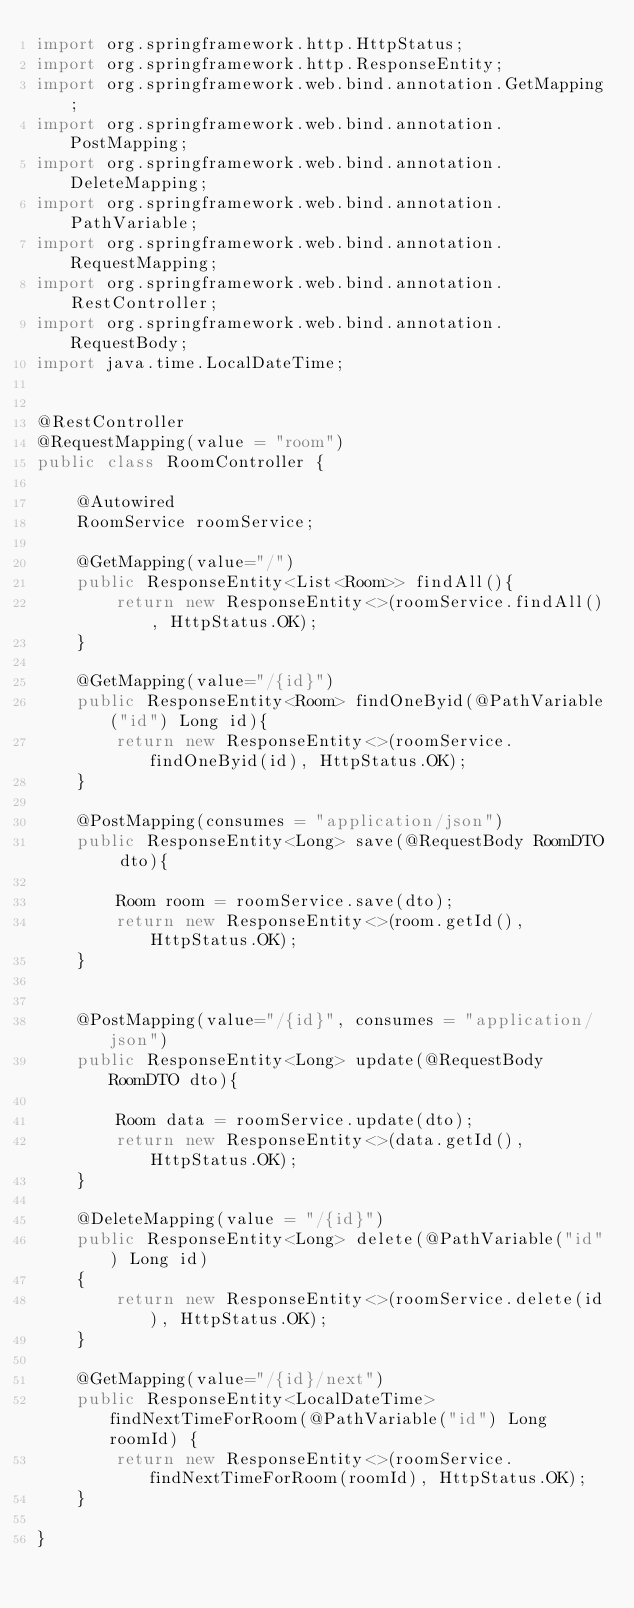<code> <loc_0><loc_0><loc_500><loc_500><_Java_>import org.springframework.http.HttpStatus;
import org.springframework.http.ResponseEntity;
import org.springframework.web.bind.annotation.GetMapping;
import org.springframework.web.bind.annotation.PostMapping;
import org.springframework.web.bind.annotation.DeleteMapping;
import org.springframework.web.bind.annotation.PathVariable;
import org.springframework.web.bind.annotation.RequestMapping;
import org.springframework.web.bind.annotation.RestController;
import org.springframework.web.bind.annotation.RequestBody;
import java.time.LocalDateTime;


@RestController
@RequestMapping(value = "room")
public class RoomController {
	
	@Autowired 
	RoomService roomService;

	@GetMapping(value="/")
	public ResponseEntity<List<Room>> findAll(){
		return new ResponseEntity<>(roomService.findAll(), HttpStatus.OK);
	}
	
	@GetMapping(value="/{id}")
	public ResponseEntity<Room> findOneByid(@PathVariable("id") Long id){
		return new ResponseEntity<>(roomService.findOneByid(id), HttpStatus.OK);
	}
	
	@PostMapping(consumes = "application/json")
	public ResponseEntity<Long> save(@RequestBody RoomDTO dto){
		
		Room room = roomService.save(dto);
		return new ResponseEntity<>(room.getId(),HttpStatus.OK);
	}
	
	
	@PostMapping(value="/{id}", consumes = "application/json")
	public ResponseEntity<Long> update(@RequestBody RoomDTO dto){
		
		Room data = roomService.update(dto);
		return new ResponseEntity<>(data.getId(),HttpStatus.OK);
	}

	@DeleteMapping(value = "/{id}")
	public ResponseEntity<Long> delete(@PathVariable("id") Long id) 
	{
		return new ResponseEntity<>(roomService.delete(id), HttpStatus.OK);
	}

	@GetMapping(value="/{id}/next")
	public ResponseEntity<LocalDateTime> findNextTimeForRoom(@PathVariable("id") Long roomId) {
		return new ResponseEntity<>(roomService.findNextTimeForRoom(roomId), HttpStatus.OK);
	}

}
</code> 